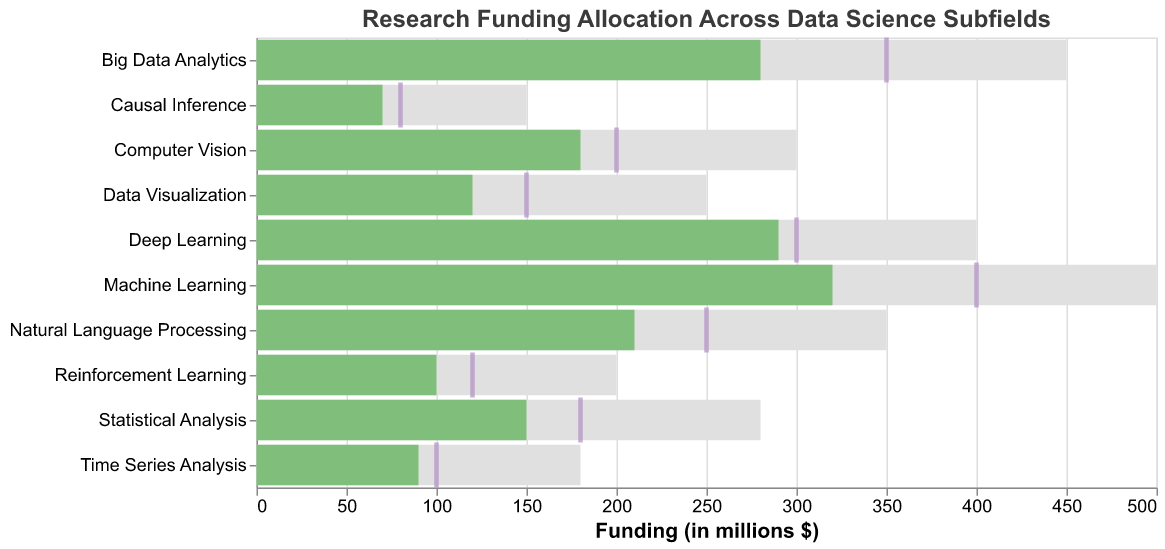What is the title of the figure? The title of the figure is usually displayed at the top of the chart. In this case, "Research Funding Allocation Across Data Science Subfields" is mentioned as the title of the figure in the code.
Answer: Research Funding Allocation Across Data Science Subfields Which subfield received the highest actual funding? By examining the lengths of the green bars (actual funding), we can see that "Machine Learning" has the longest bar, indicating the highest actual funding.
Answer: Machine Learning What is the maximum funding allocated for Deep Learning? The grey bar represents the maximum funding. For the "Deep Learning" subfield, the corresponding grey bar reaches up to the value 400.
Answer: 400 How much lower is the actual funding for Reinforcement Learning compared to its target funding? The actual funding for Reinforcement Learning is shown as 100 (green bar), and the target funding is represented by a tick mark at 120. Subtract the actual funding from the target funding (120 - 100).
Answer: 20 What are the three subfields with the smallest actual funding amounts? By identifying the shortest green bars, we find that "Causal Inference," "Time Series Analysis," and "Reinforcement Learning" have the shortest bars.
Answer: Causal Inference, Time Series Analysis, Reinforcement Learning Which subfield is closest to meeting its target funding? Compare the distance between the actual funding (green bar) and the target funding (purple tick). "Deep Learning" has its actual funding very close to its target funding.
Answer: Deep Learning Calculate the total actual funding for Big Data Analytics and Natural Language Processing. Sum the actual funding for Big Data Analytics (280) and Natural Language Processing (210). The total is 280 + 210.
Answer: 490 Is there any subfield where the actual funding exceeded the target funding? Compare the lengths of the green bars (actual funding) to the position of the purple ticks (target funding). No green bar exceeds the position of any purple tick.
Answer: No Which subfield has the largest gap between actual and maximum funding? Calculate the difference between the maximum and actual funding for each subfield. "Reinforcement Learning" has a maximum funding of 200 and an actual funding of 100, leading to a gap of 100.
Answer: Reinforcement Learning Arrange the subfields in descending order of their actual funding amounts. Rank the subfields by the length of their green bars from longest to shortest: Machine Learning (320), Deep Learning (290), Big Data Analytics (280), Natural Language Processing (210), Computer Vision (180), Statistical Analysis (150), Data Visualization (120), Reinforcement Learning (100), Time Series Analysis (90), Causal Inference (70).
Answer: Machine Learning, Deep Learning, Big Data Analytics, Natural Language Processing, Computer Vision, Statistical Analysis, Data Visualization, Reinforcement Learning, Time Series Analysis, Causal Inference 